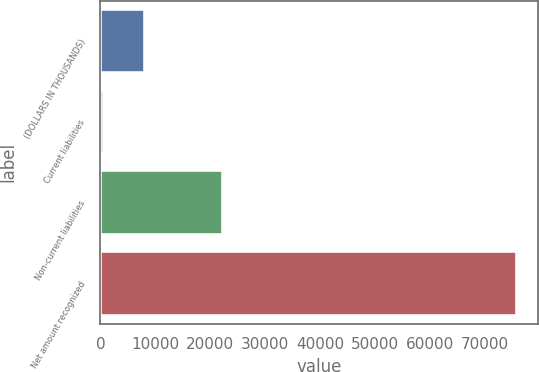Convert chart. <chart><loc_0><loc_0><loc_500><loc_500><bar_chart><fcel>(DOLLARS IN THOUSANDS)<fcel>Current liabilities<fcel>Non-current liabilities<fcel>Net amount recognized<nl><fcel>8137.2<fcel>610<fcel>22323<fcel>75882<nl></chart> 